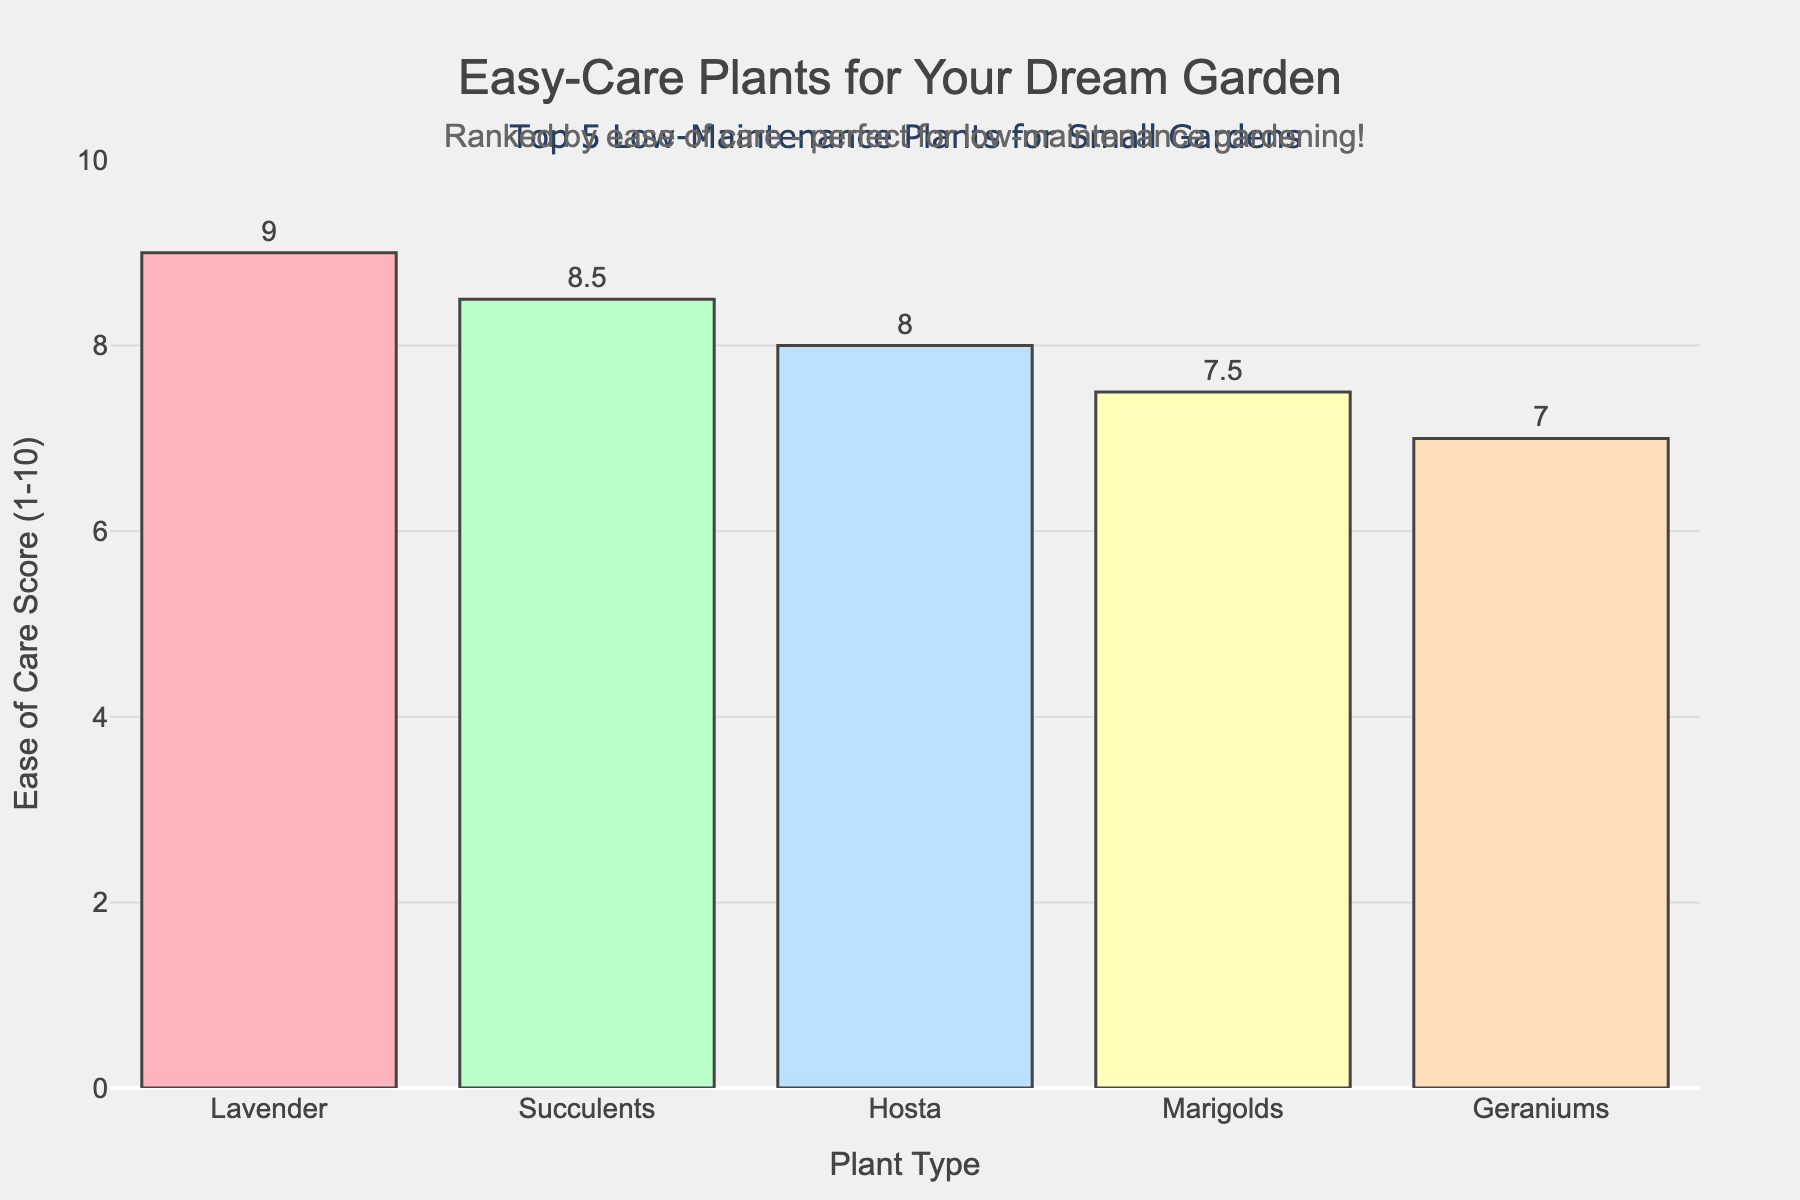What's the highest Ease of Care Score? The highest Ease of Care Score is shown by the tallest bar on the chart, which belongs to Lavender with a score of 9.
Answer: 9 Which plant has the lowest Ease of Care Score? The lowest Ease of Care Score is represented by the shortest bar on the chart, which belongs to Geraniums with a score of 7.
Answer: Geraniums Which plants have an Ease of Care Score greater than 8? The plants with an Ease of Care Score greater than 8 are represented by bars taller than the 8 mark on the y-axis. These plants are Lavender with a score of 9 and Succulents with a score of 8.5.
Answer: Lavender, Succulents What is the Ease of Care Score difference between Marigolds and Hosta? Marigolds have a score of 7.5, and Hosta has a score of 8. The difference is calculated by subtracting the lower score from the higher score: 8 - 7.5 = 0.5.
Answer: 0.5 Rank the plants from highest to lowest Ease of Care Score. The ranking from highest to lowest Ease of Care Score can be determined by comparing the heights of the bars: Lavender (9), Succulents (8.5), Hosta (8), Marigolds (7.5), Geraniums (7).
Answer: Lavender, Succulents, Hosta, Marigolds, Geraniums If you combine the Ease of Care Scores of the three highest-scoring plants, what is the total? The three highest-scoring plants are Lavender (9), Succulents (8.5), and Hosta (8). Adding these scores together: 9 + 8.5 + 8 = 25.5.
Answer: 25.5 By how much does Geraniums' score fall short of Lavender's score? Geraniums have a score of 7 and Lavender has a score of 9. The difference is calculated by subtracting the lower score from the higher score: 9 - 7 = 2.
Answer: 2 If you average the Ease of Care Scores of all five plants, what is the result? The total of all scores is 9 + 8.5 + 8 + 7.5 + 7 = 40. Dividing by the number of plants (5) gives the average: 40 / 5 = 8.
Answer: 8 